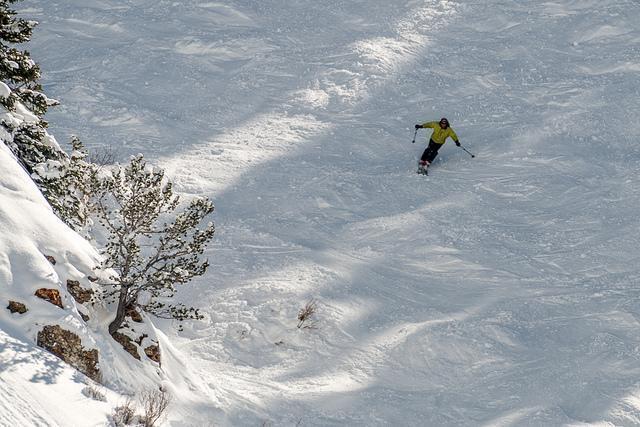How many skiers are there?
Give a very brief answer. 1. 